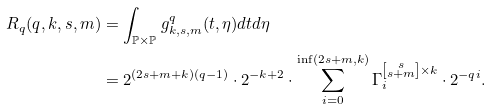Convert formula to latex. <formula><loc_0><loc_0><loc_500><loc_500>R _ { q } ( q , k , s , m ) & = \int _ { \mathbb { P } \times \mathbb { P } } g _ { k , s , m } ^ { q } ( t , \eta ) d t d \eta \\ & = 2 ^ { ( 2 s + m + k ) ( q - 1 ) } \cdot 2 ^ { - k + 2 } \cdot \sum _ { i = 0 } ^ { \inf ( 2 s + m , k ) } \Gamma _ { i } ^ { \left [ \substack { s \\ s + m } \right ] \times k } \cdot 2 ^ { - q i } .</formula> 